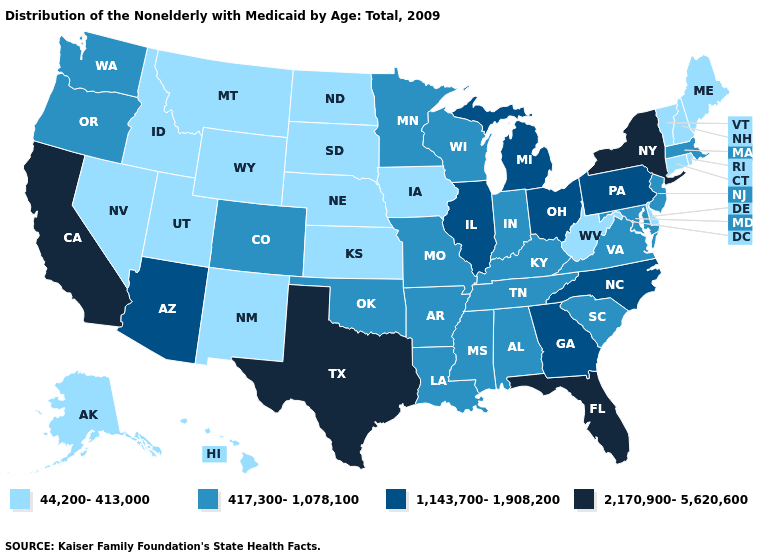Among the states that border Kansas , which have the highest value?
Short answer required. Colorado, Missouri, Oklahoma. Which states have the highest value in the USA?
Be succinct. California, Florida, New York, Texas. Among the states that border Pennsylvania , which have the highest value?
Write a very short answer. New York. What is the value of Tennessee?
Be succinct. 417,300-1,078,100. Does Kansas have the lowest value in the MidWest?
Answer briefly. Yes. What is the lowest value in the West?
Keep it brief. 44,200-413,000. Name the states that have a value in the range 44,200-413,000?
Keep it brief. Alaska, Connecticut, Delaware, Hawaii, Idaho, Iowa, Kansas, Maine, Montana, Nebraska, Nevada, New Hampshire, New Mexico, North Dakota, Rhode Island, South Dakota, Utah, Vermont, West Virginia, Wyoming. Which states have the highest value in the USA?
Concise answer only. California, Florida, New York, Texas. Name the states that have a value in the range 44,200-413,000?
Quick response, please. Alaska, Connecticut, Delaware, Hawaii, Idaho, Iowa, Kansas, Maine, Montana, Nebraska, Nevada, New Hampshire, New Mexico, North Dakota, Rhode Island, South Dakota, Utah, Vermont, West Virginia, Wyoming. Which states have the highest value in the USA?
Concise answer only. California, Florida, New York, Texas. Does the map have missing data?
Quick response, please. No. Among the states that border North Dakota , does Montana have the highest value?
Give a very brief answer. No. What is the lowest value in states that border Minnesota?
Concise answer only. 44,200-413,000. Among the states that border Connecticut , which have the lowest value?
Quick response, please. Rhode Island. Does Nevada have the lowest value in the West?
Give a very brief answer. Yes. 